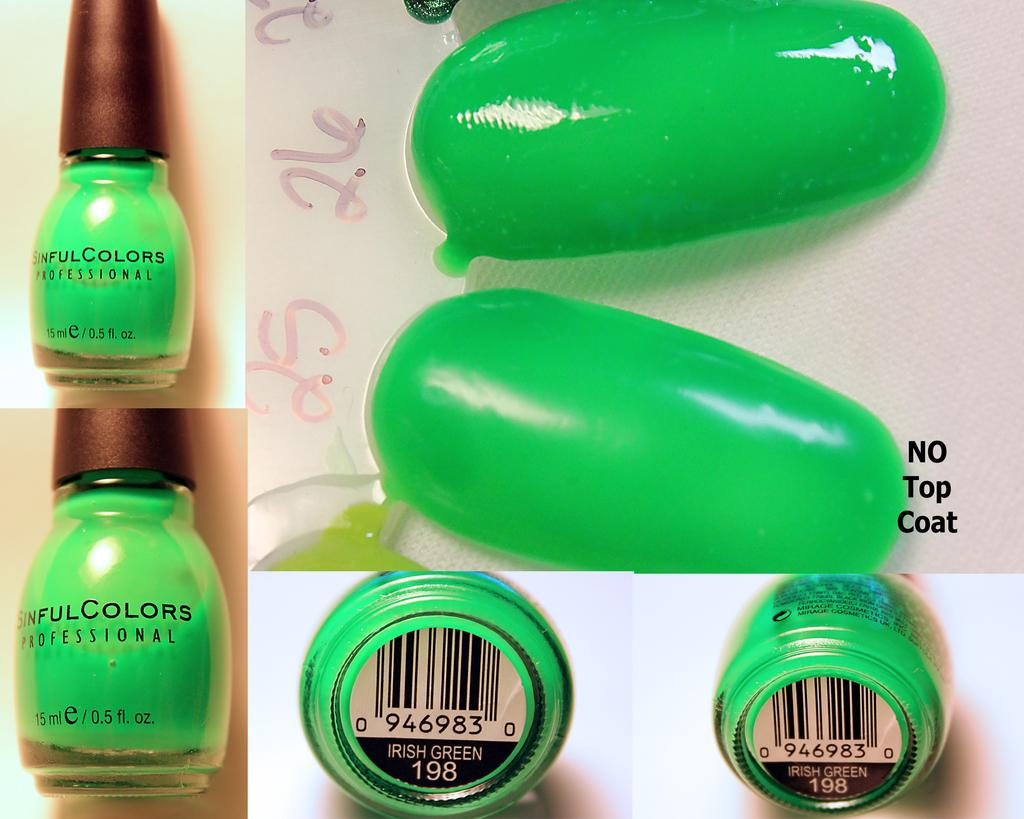Provide a one-sentence caption for the provided image. A collage featuring Sinful Colors irish green nail polish. 